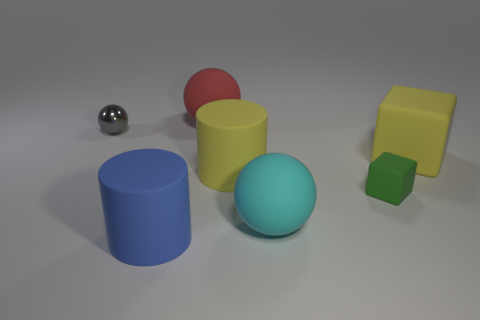Add 1 large yellow cylinders. How many objects exist? 8 Subtract all cylinders. How many objects are left? 5 Subtract 1 red spheres. How many objects are left? 6 Subtract all cyan things. Subtract all small green rubber objects. How many objects are left? 5 Add 7 spheres. How many spheres are left? 10 Add 4 large purple things. How many large purple things exist? 4 